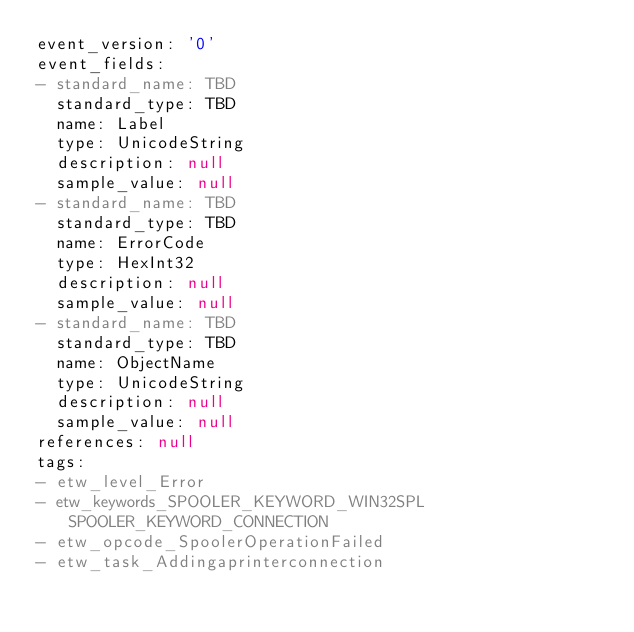Convert code to text. <code><loc_0><loc_0><loc_500><loc_500><_YAML_>event_version: '0'
event_fields:
- standard_name: TBD
  standard_type: TBD
  name: Label
  type: UnicodeString
  description: null
  sample_value: null
- standard_name: TBD
  standard_type: TBD
  name: ErrorCode
  type: HexInt32
  description: null
  sample_value: null
- standard_name: TBD
  standard_type: TBD
  name: ObjectName
  type: UnicodeString
  description: null
  sample_value: null
references: null
tags:
- etw_level_Error
- etw_keywords_SPOOLER_KEYWORD_WIN32SPL SPOOLER_KEYWORD_CONNECTION
- etw_opcode_SpoolerOperationFailed
- etw_task_Addingaprinterconnection
</code> 